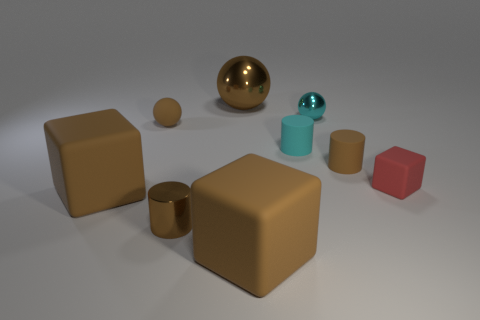Subtract all small metallic balls. How many balls are left? 2 Add 1 big red shiny blocks. How many objects exist? 10 Subtract 3 cubes. How many cubes are left? 0 Subtract all brown blocks. How many blocks are left? 1 Subtract 0 purple balls. How many objects are left? 9 Subtract all cubes. How many objects are left? 6 Subtract all purple cubes. Subtract all blue cylinders. How many cubes are left? 3 Subtract all red spheres. How many brown blocks are left? 2 Subtract all tiny blue matte blocks. Subtract all brown rubber cylinders. How many objects are left? 8 Add 1 red blocks. How many red blocks are left? 2 